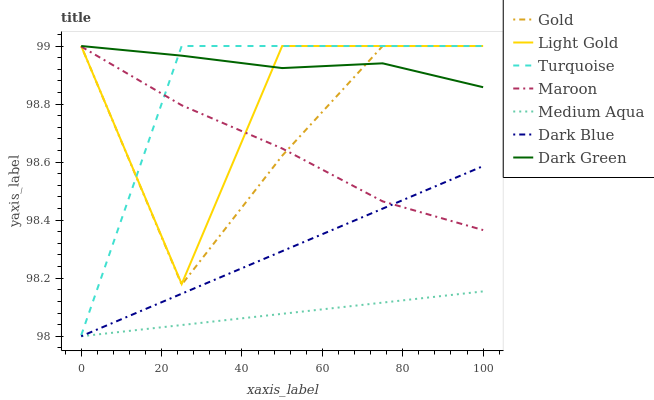Does Medium Aqua have the minimum area under the curve?
Answer yes or no. Yes. Does Dark Green have the maximum area under the curve?
Answer yes or no. Yes. Does Gold have the minimum area under the curve?
Answer yes or no. No. Does Gold have the maximum area under the curve?
Answer yes or no. No. Is Dark Blue the smoothest?
Answer yes or no. Yes. Is Light Gold the roughest?
Answer yes or no. Yes. Is Gold the smoothest?
Answer yes or no. No. Is Gold the roughest?
Answer yes or no. No. Does Dark Blue have the lowest value?
Answer yes or no. Yes. Does Gold have the lowest value?
Answer yes or no. No. Does Dark Green have the highest value?
Answer yes or no. Yes. Does Maroon have the highest value?
Answer yes or no. No. Is Dark Blue less than Dark Green?
Answer yes or no. Yes. Is Dark Green greater than Maroon?
Answer yes or no. Yes. Does Dark Green intersect Gold?
Answer yes or no. Yes. Is Dark Green less than Gold?
Answer yes or no. No. Is Dark Green greater than Gold?
Answer yes or no. No. Does Dark Blue intersect Dark Green?
Answer yes or no. No. 